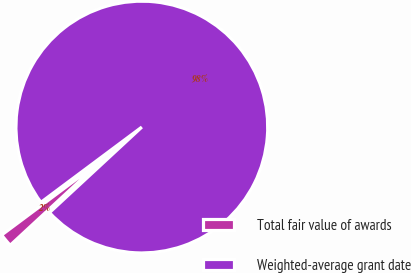<chart> <loc_0><loc_0><loc_500><loc_500><pie_chart><fcel>Total fair value of awards<fcel>Weighted-average grant date<nl><fcel>1.69%<fcel>98.31%<nl></chart> 